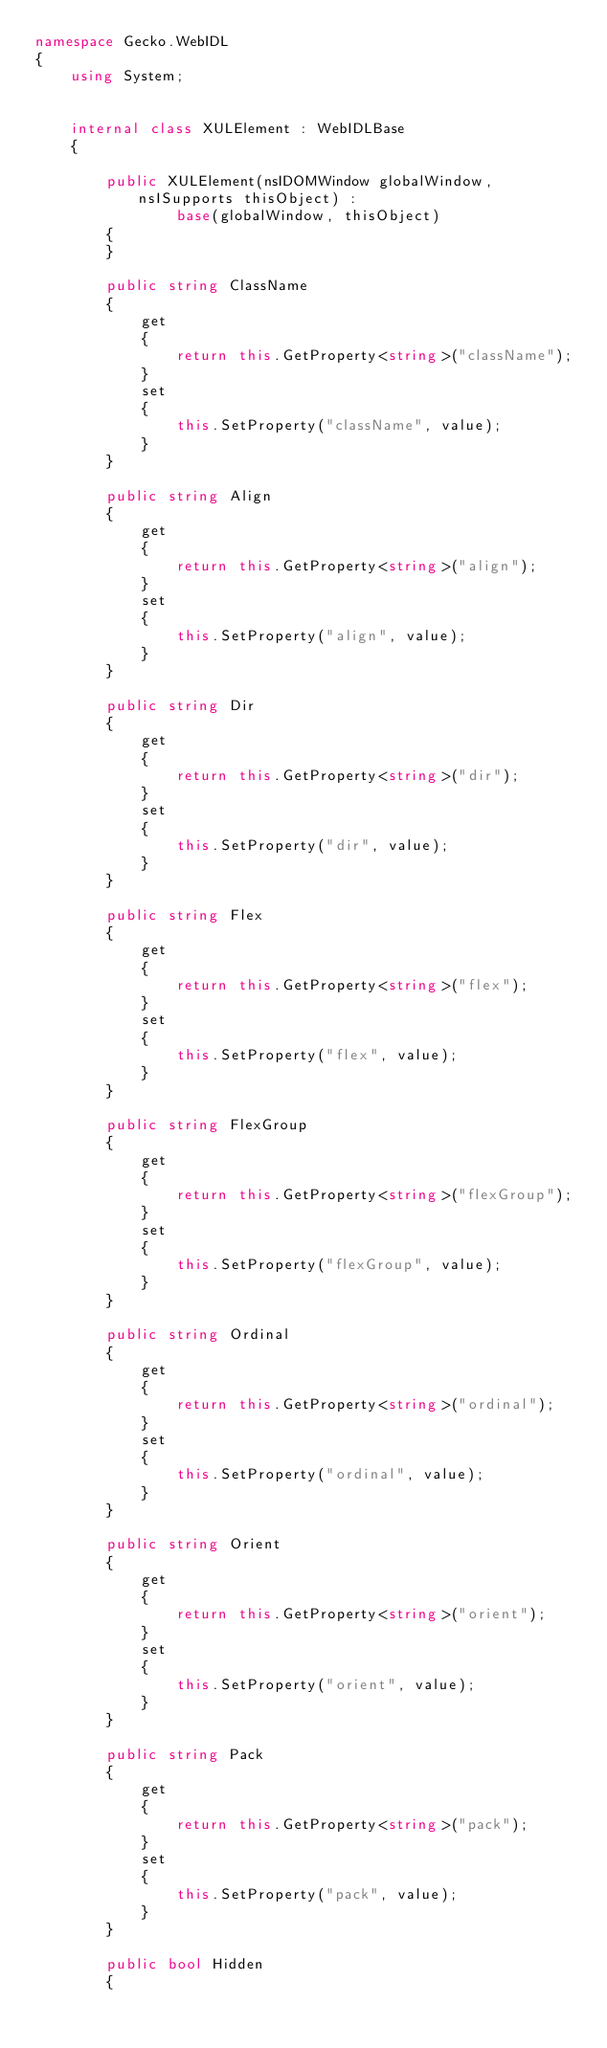<code> <loc_0><loc_0><loc_500><loc_500><_C#_>namespace Gecko.WebIDL
{
    using System;
    
    
    internal class XULElement : WebIDLBase
    {
        
        public XULElement(nsIDOMWindow globalWindow, nsISupports thisObject) : 
                base(globalWindow, thisObject)
        {
        }
        
        public string ClassName
        {
            get
            {
                return this.GetProperty<string>("className");
            }
            set
            {
                this.SetProperty("className", value);
            }
        }
        
        public string Align
        {
            get
            {
                return this.GetProperty<string>("align");
            }
            set
            {
                this.SetProperty("align", value);
            }
        }
        
        public string Dir
        {
            get
            {
                return this.GetProperty<string>("dir");
            }
            set
            {
                this.SetProperty("dir", value);
            }
        }
        
        public string Flex
        {
            get
            {
                return this.GetProperty<string>("flex");
            }
            set
            {
                this.SetProperty("flex", value);
            }
        }
        
        public string FlexGroup
        {
            get
            {
                return this.GetProperty<string>("flexGroup");
            }
            set
            {
                this.SetProperty("flexGroup", value);
            }
        }
        
        public string Ordinal
        {
            get
            {
                return this.GetProperty<string>("ordinal");
            }
            set
            {
                this.SetProperty("ordinal", value);
            }
        }
        
        public string Orient
        {
            get
            {
                return this.GetProperty<string>("orient");
            }
            set
            {
                this.SetProperty("orient", value);
            }
        }
        
        public string Pack
        {
            get
            {
                return this.GetProperty<string>("pack");
            }
            set
            {
                this.SetProperty("pack", value);
            }
        }
        
        public bool Hidden
        {</code> 